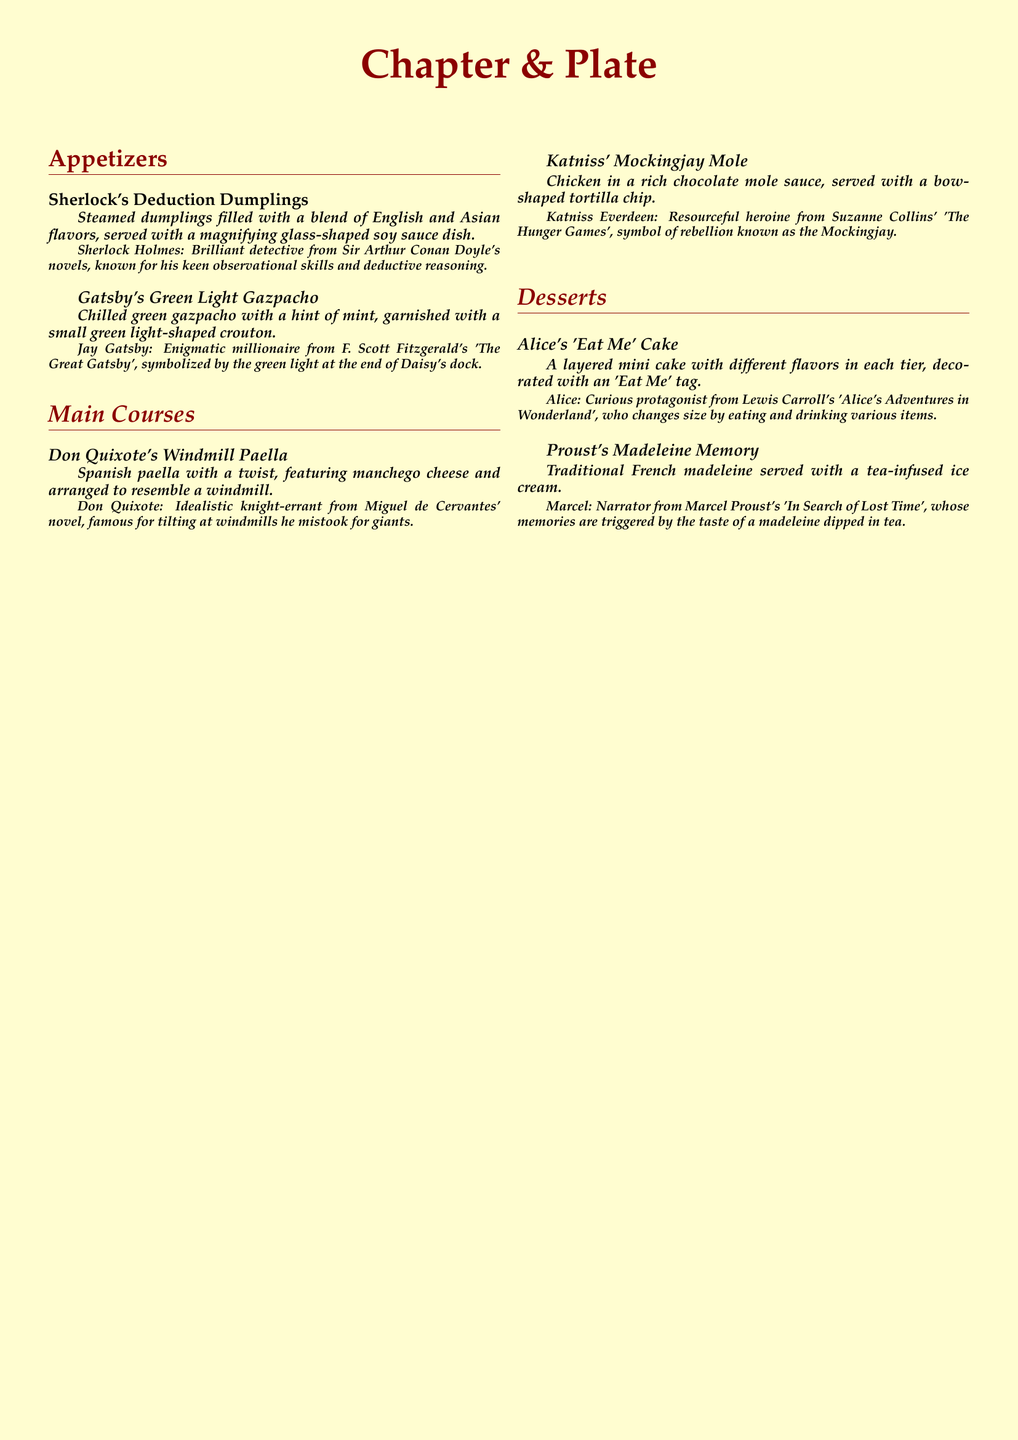What is the name of the appetizer inspired by Sherlock Holmes? The menu lists "Sherlock's Deduction Dumplings" as the appetizer inspired by Sherlock Holmes.
Answer: Sherlock's Deduction Dumplings Which main course features a Spanish twist and is named after a knight-errant? The dish "Don Quixote's Windmill Paella" is the main course that has a Spanish twist and is named after the idealistic knight-errant, Don Quixote.
Answer: Don Quixote's Windmill Paella What type of sauce accompanies Katniss' main course? Katniss' main course, "Katniss' Mockingjay Mole," features chicken served with a rich chocolate mole sauce.
Answer: chocolate mole sauce How many layers does Alice's dessert cake have? Alice's dessert, "Alice's 'Eat Me' Cake," is described as a layered mini cake, though the exact number of layers is not specified, it's implied to have multiple layers.
Answer: layered Which character is associated with the symbol of a green light? Jay Gatsby, the character from 'The Great Gatsby', is associated with the symbol of a green light.
Answer: Jay Gatsby What type of tea-flavored dessert is included in the menu? The dessert "Proust's Madeleine Memory" includes a tea-infused ice cream, suggesting a tea flavor component.
Answer: tea-infused ice cream What is used to garnish Gatsby's gazpacho? The gazpacho is garnished with a small green light-shaped crouton.
Answer: green light-shaped crouton Which character is known as a resourceful heroine in a dystopian setting? Katniss Everdeen is described as a resourceful heroine from 'The Hunger Games'.
Answer: Katniss Everdeen What is the color scheme used for the document background? The document background is described as cream-colored.
Answer: cream 